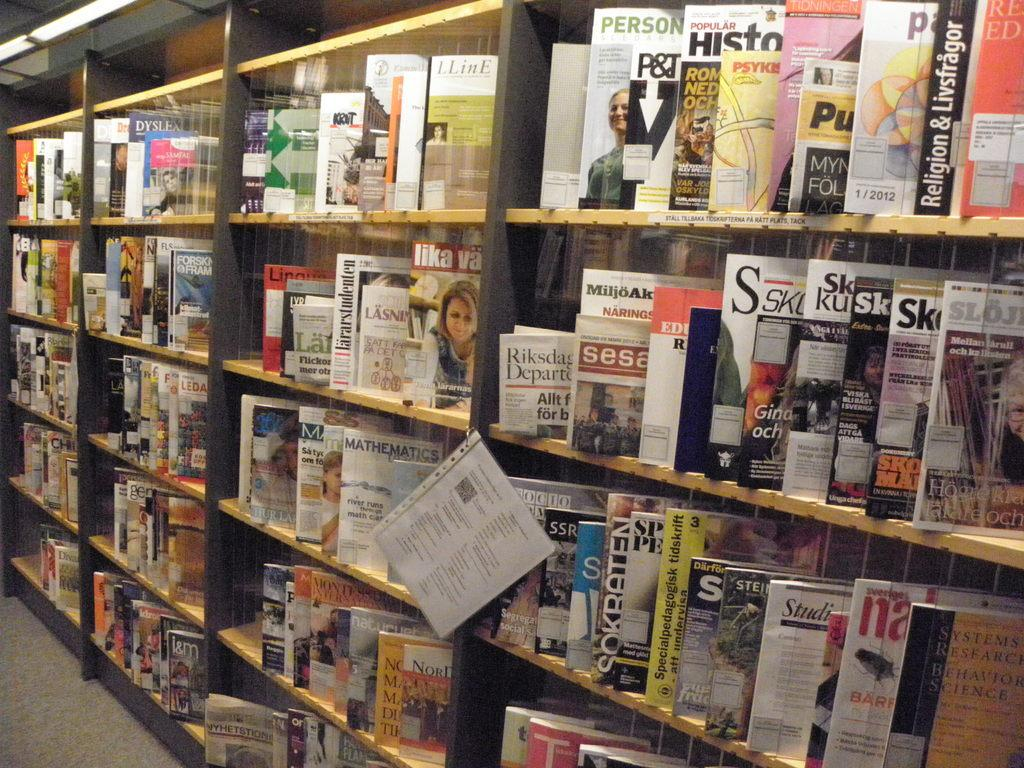What objects are present in the image? There are books in the image. Where are the books located? The books are on bookshelves. What else can be seen in the image besides books? There is a paper with text visible in the image. What animals can be seen at the zoo in the image? There is no zoo or animals present in the image; it features books on bookshelves and a paper with text. What idea is being conveyed by the top of the bookshelf in the image? There is no idea being conveyed by the top of the bookshelf in the image, as it is simply the top of the bookshelf. 